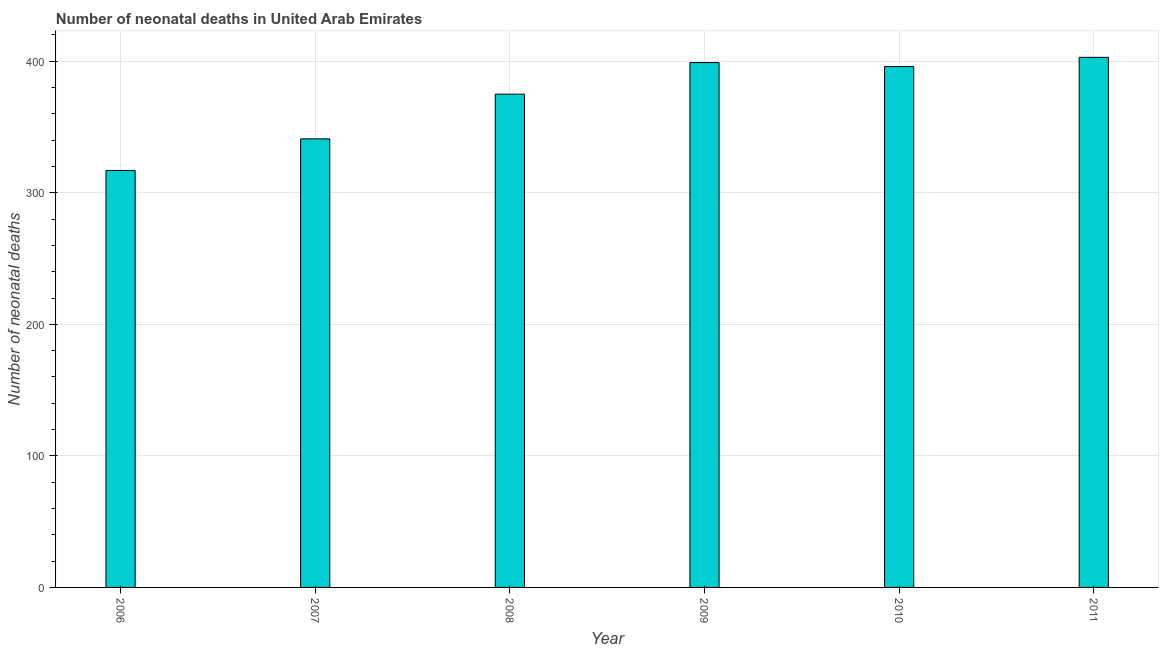Does the graph contain any zero values?
Your answer should be compact. No. What is the title of the graph?
Offer a very short reply. Number of neonatal deaths in United Arab Emirates. What is the label or title of the X-axis?
Ensure brevity in your answer.  Year. What is the label or title of the Y-axis?
Keep it short and to the point. Number of neonatal deaths. What is the number of neonatal deaths in 2011?
Offer a terse response. 403. Across all years, what is the maximum number of neonatal deaths?
Offer a very short reply. 403. Across all years, what is the minimum number of neonatal deaths?
Provide a succinct answer. 317. In which year was the number of neonatal deaths maximum?
Offer a very short reply. 2011. In which year was the number of neonatal deaths minimum?
Provide a succinct answer. 2006. What is the sum of the number of neonatal deaths?
Provide a succinct answer. 2231. What is the difference between the number of neonatal deaths in 2007 and 2008?
Provide a succinct answer. -34. What is the average number of neonatal deaths per year?
Offer a very short reply. 371. What is the median number of neonatal deaths?
Your answer should be very brief. 385.5. What is the ratio of the number of neonatal deaths in 2007 to that in 2010?
Your response must be concise. 0.86. Is the sum of the number of neonatal deaths in 2006 and 2007 greater than the maximum number of neonatal deaths across all years?
Provide a succinct answer. Yes. What is the difference between the highest and the lowest number of neonatal deaths?
Offer a terse response. 86. Are all the bars in the graph horizontal?
Offer a very short reply. No. How many years are there in the graph?
Ensure brevity in your answer.  6. What is the difference between two consecutive major ticks on the Y-axis?
Your response must be concise. 100. What is the Number of neonatal deaths in 2006?
Make the answer very short. 317. What is the Number of neonatal deaths in 2007?
Ensure brevity in your answer.  341. What is the Number of neonatal deaths in 2008?
Offer a terse response. 375. What is the Number of neonatal deaths in 2009?
Your answer should be compact. 399. What is the Number of neonatal deaths in 2010?
Offer a terse response. 396. What is the Number of neonatal deaths in 2011?
Give a very brief answer. 403. What is the difference between the Number of neonatal deaths in 2006 and 2007?
Your answer should be very brief. -24. What is the difference between the Number of neonatal deaths in 2006 and 2008?
Keep it short and to the point. -58. What is the difference between the Number of neonatal deaths in 2006 and 2009?
Ensure brevity in your answer.  -82. What is the difference between the Number of neonatal deaths in 2006 and 2010?
Ensure brevity in your answer.  -79. What is the difference between the Number of neonatal deaths in 2006 and 2011?
Keep it short and to the point. -86. What is the difference between the Number of neonatal deaths in 2007 and 2008?
Make the answer very short. -34. What is the difference between the Number of neonatal deaths in 2007 and 2009?
Keep it short and to the point. -58. What is the difference between the Number of neonatal deaths in 2007 and 2010?
Keep it short and to the point. -55. What is the difference between the Number of neonatal deaths in 2007 and 2011?
Offer a terse response. -62. What is the difference between the Number of neonatal deaths in 2008 and 2009?
Offer a terse response. -24. What is the difference between the Number of neonatal deaths in 2008 and 2010?
Your answer should be very brief. -21. What is the difference between the Number of neonatal deaths in 2008 and 2011?
Offer a terse response. -28. What is the difference between the Number of neonatal deaths in 2009 and 2010?
Your answer should be very brief. 3. What is the difference between the Number of neonatal deaths in 2009 and 2011?
Give a very brief answer. -4. What is the ratio of the Number of neonatal deaths in 2006 to that in 2008?
Offer a very short reply. 0.84. What is the ratio of the Number of neonatal deaths in 2006 to that in 2009?
Provide a short and direct response. 0.79. What is the ratio of the Number of neonatal deaths in 2006 to that in 2010?
Your answer should be very brief. 0.8. What is the ratio of the Number of neonatal deaths in 2006 to that in 2011?
Your response must be concise. 0.79. What is the ratio of the Number of neonatal deaths in 2007 to that in 2008?
Ensure brevity in your answer.  0.91. What is the ratio of the Number of neonatal deaths in 2007 to that in 2009?
Offer a very short reply. 0.85. What is the ratio of the Number of neonatal deaths in 2007 to that in 2010?
Offer a terse response. 0.86. What is the ratio of the Number of neonatal deaths in 2007 to that in 2011?
Offer a very short reply. 0.85. What is the ratio of the Number of neonatal deaths in 2008 to that in 2009?
Offer a very short reply. 0.94. What is the ratio of the Number of neonatal deaths in 2008 to that in 2010?
Ensure brevity in your answer.  0.95. What is the ratio of the Number of neonatal deaths in 2009 to that in 2011?
Offer a very short reply. 0.99. What is the ratio of the Number of neonatal deaths in 2010 to that in 2011?
Make the answer very short. 0.98. 